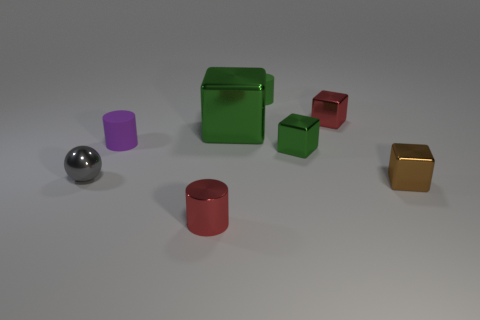Subtract all red cubes. How many cubes are left? 3 Add 2 brown objects. How many objects exist? 10 Subtract all red cylinders. How many cylinders are left? 2 Subtract all yellow balls. How many green blocks are left? 2 Subtract all cylinders. How many objects are left? 5 Subtract 1 red cylinders. How many objects are left? 7 Subtract all cyan cubes. Subtract all cyan cylinders. How many cubes are left? 4 Subtract all rubber blocks. Subtract all small brown objects. How many objects are left? 7 Add 8 tiny green matte cylinders. How many tiny green matte cylinders are left? 9 Add 2 balls. How many balls exist? 3 